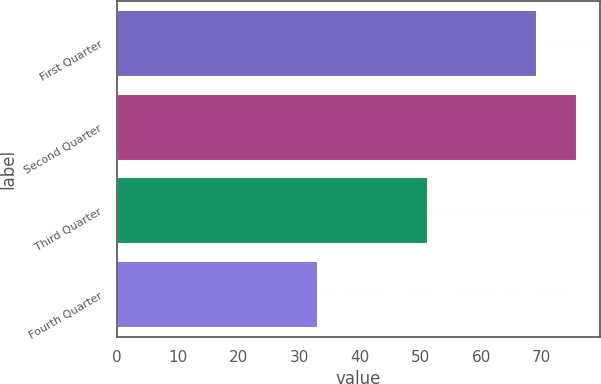<chart> <loc_0><loc_0><loc_500><loc_500><bar_chart><fcel>First Quarter<fcel>Second Quarter<fcel>Third Quarter<fcel>Fourth Quarter<nl><fcel>69.18<fcel>75.79<fcel>51.18<fcel>33.15<nl></chart> 